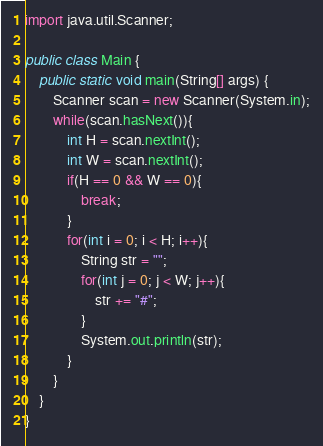<code> <loc_0><loc_0><loc_500><loc_500><_Java_>import java.util.Scanner;

public class Main {
	public static void main(String[] args) {
		Scanner scan = new Scanner(System.in);
		while(scan.hasNext()){
			int H = scan.nextInt();
			int W = scan.nextInt();
			if(H == 0 && W == 0){
				break;
			}
			for(int i = 0; i < H; i++){
				String str = "";
				for(int j = 0; j < W; j++){
					str += "#";
				}
				System.out.println(str);
			}
		}
	}
}</code> 